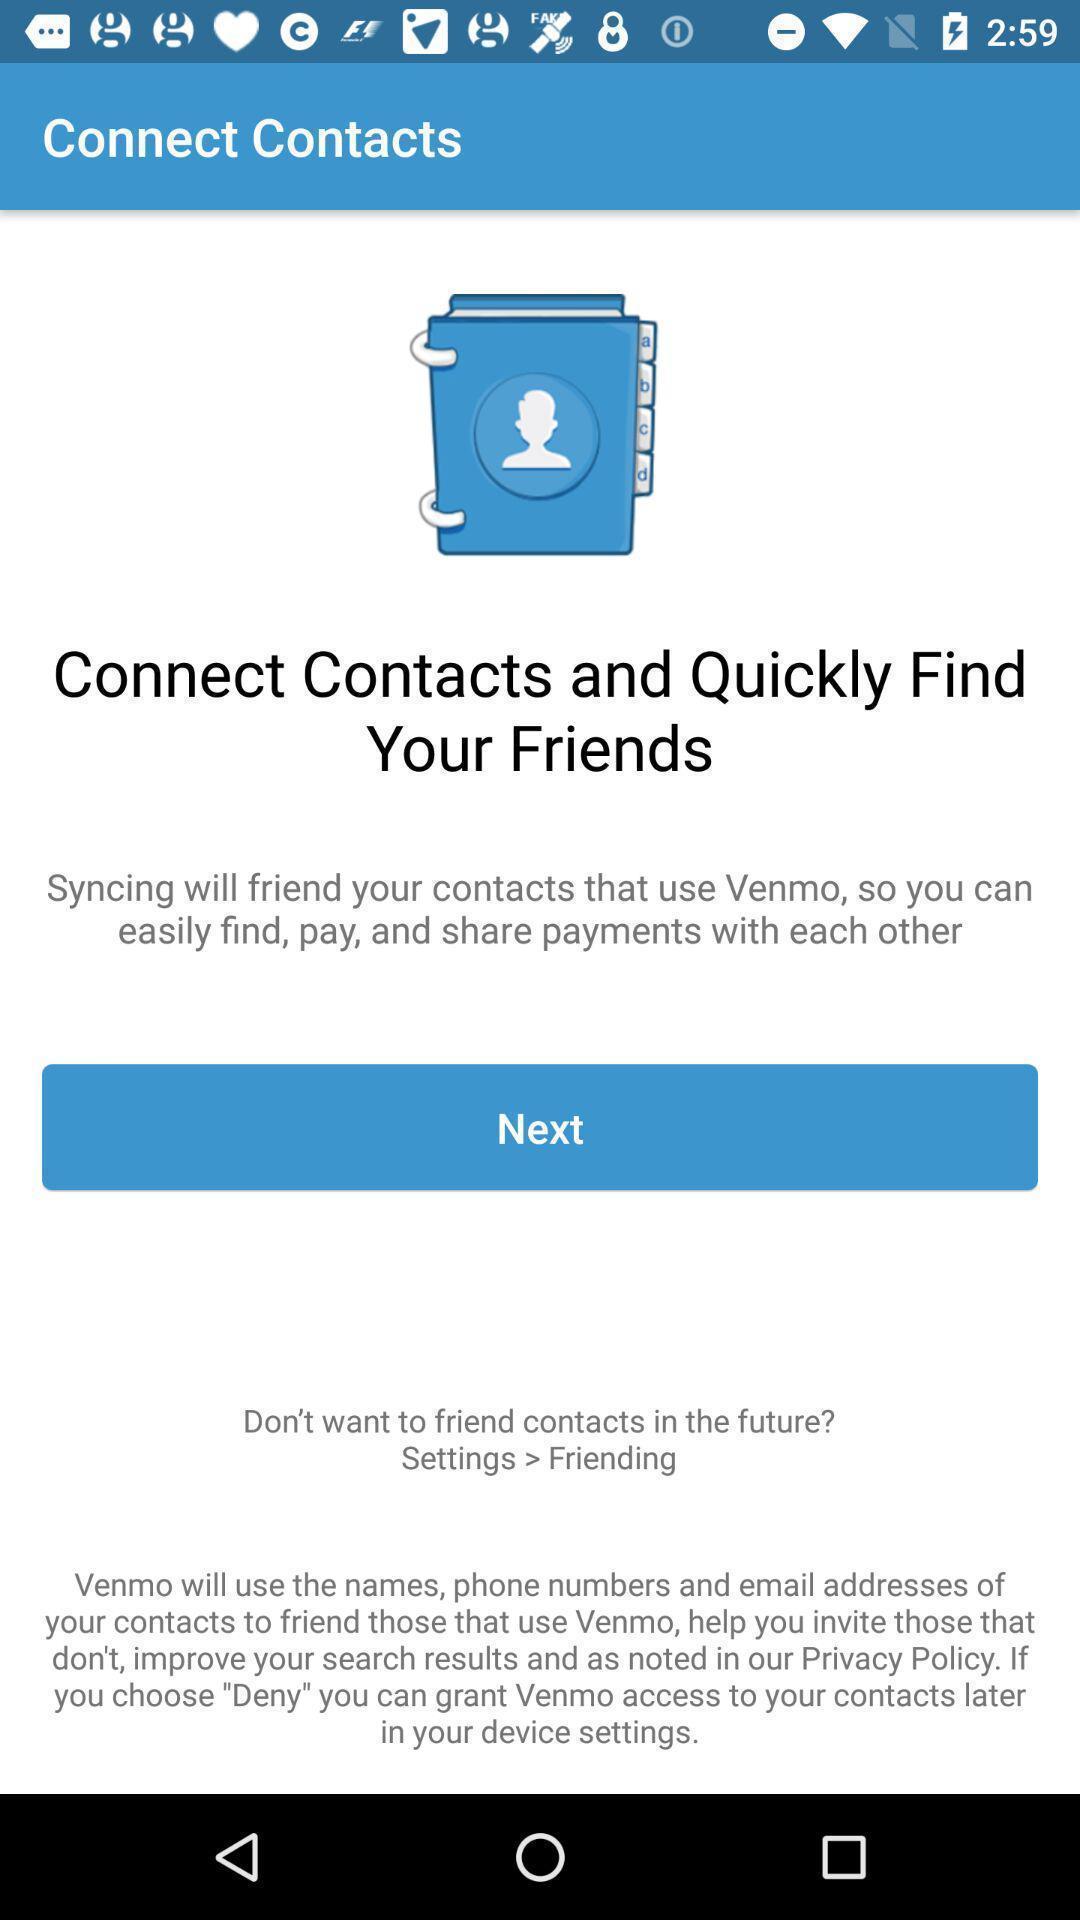Please provide a description for this image. Page shows some information in an financial application. 